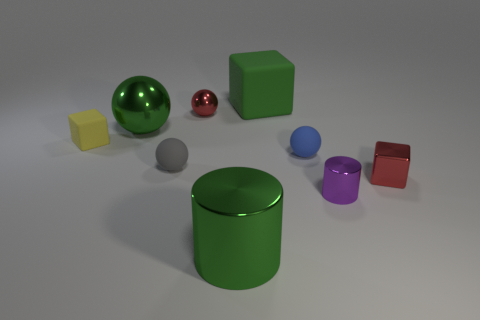Subtract all green blocks. How many blocks are left? 2 Subtract all gray balls. How many balls are left? 3 Subtract all cylinders. How many objects are left? 7 Subtract 1 spheres. How many spheres are left? 3 Subtract all blue blocks. Subtract all purple cylinders. How many blocks are left? 3 Subtract all large metal spheres. Subtract all green spheres. How many objects are left? 7 Add 4 tiny red blocks. How many tiny red blocks are left? 5 Add 5 green things. How many green things exist? 8 Subtract 0 cyan spheres. How many objects are left? 9 